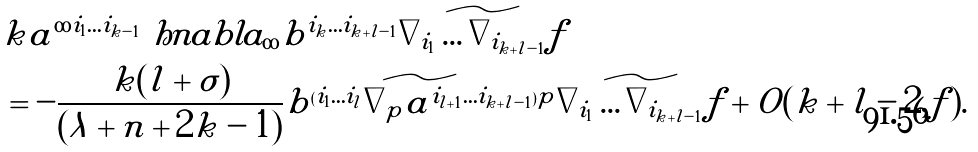Convert formula to latex. <formula><loc_0><loc_0><loc_500><loc_500>& k \tilde { a } ^ { \infty i _ { 1 } \dots i _ { k - 1 } } \ h n a b l a _ { \infty } \tilde { b } ^ { i _ { k } \dots i _ { k + l - 1 } } \widetilde { \nabla _ { i _ { 1 } } \dots \nabla _ { i _ { k + l - 1 } } f } \\ & = - \frac { k ( l + \sigma ) } { ( \lambda + n + 2 k - 1 ) } \widetilde { b ^ { ( i _ { 1 } \dots i _ { l } } \nabla _ { p } a ^ { i _ { l + 1 } \dots i _ { k + l - 1 } ) p } } \widetilde { \nabla _ { i _ { 1 } } \dots \nabla _ { i _ { k + l - 1 } } f } + O ( k + l - 2 , f ) .</formula> 